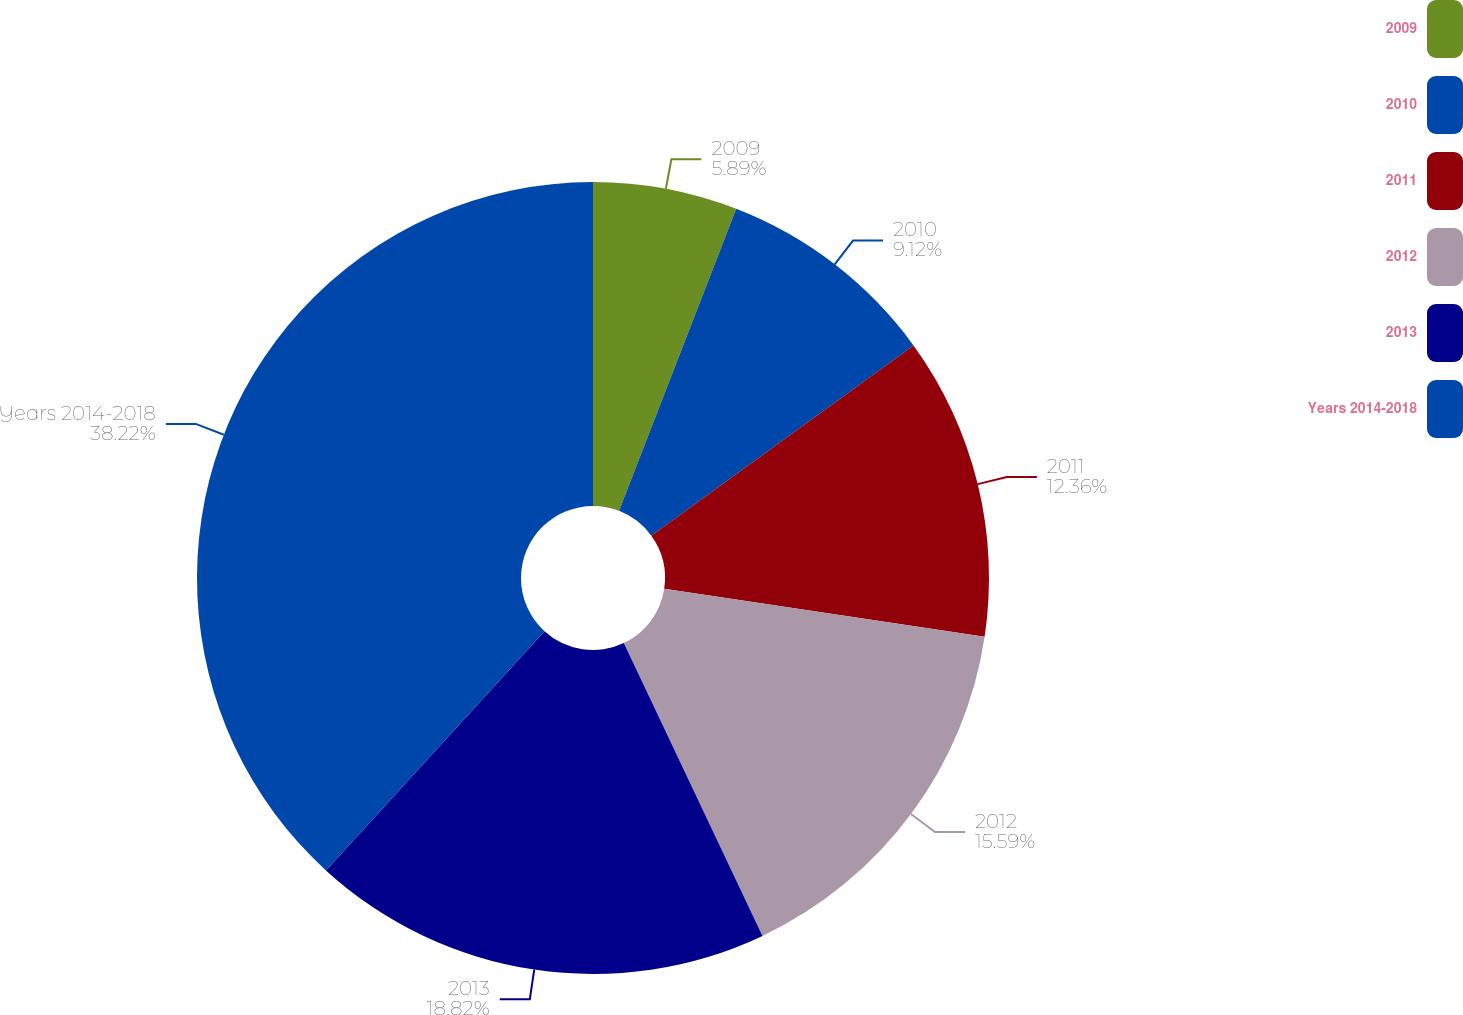Convert chart to OTSL. <chart><loc_0><loc_0><loc_500><loc_500><pie_chart><fcel>2009<fcel>2010<fcel>2011<fcel>2012<fcel>2013<fcel>Years 2014-2018<nl><fcel>5.89%<fcel>9.12%<fcel>12.36%<fcel>15.59%<fcel>18.82%<fcel>38.22%<nl></chart> 